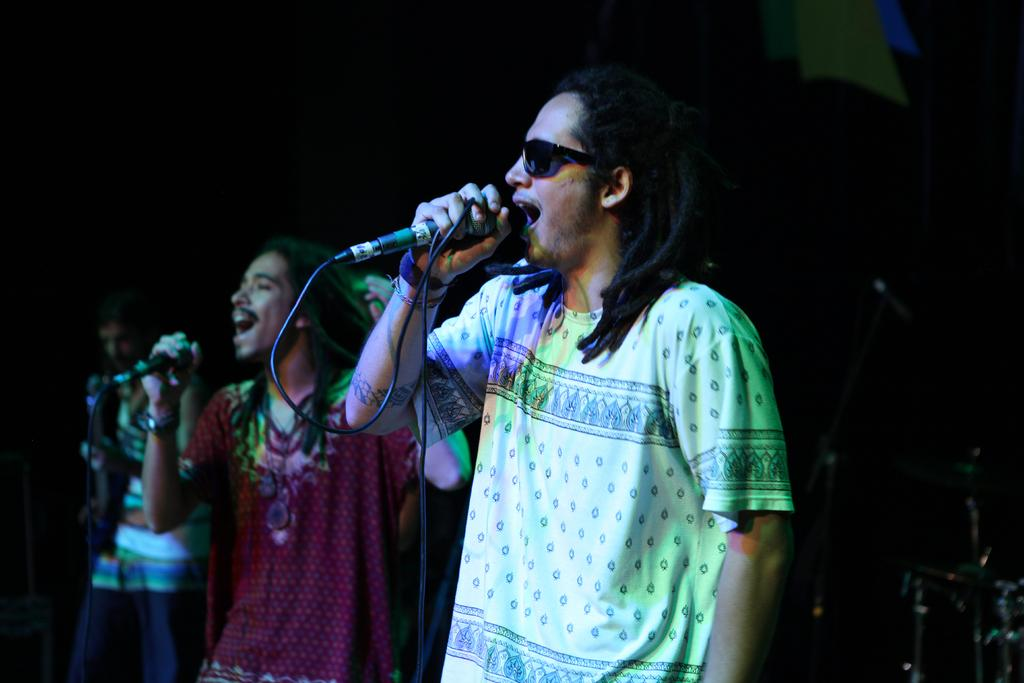How many people are in the image? There are two members in the image. What are the members holding in the image? Both members are holding microphones. Can you describe one of the members' appearance? One of the members is wearing spectacles. What is the color of the background in the image? The background of the image is dark. What type of rhythm can be heard from the mine in the image? There is no mine present in the image, and therefore no rhythm can be heard. Is there a notebook visible in the image? There is no notebook visible in the image. 